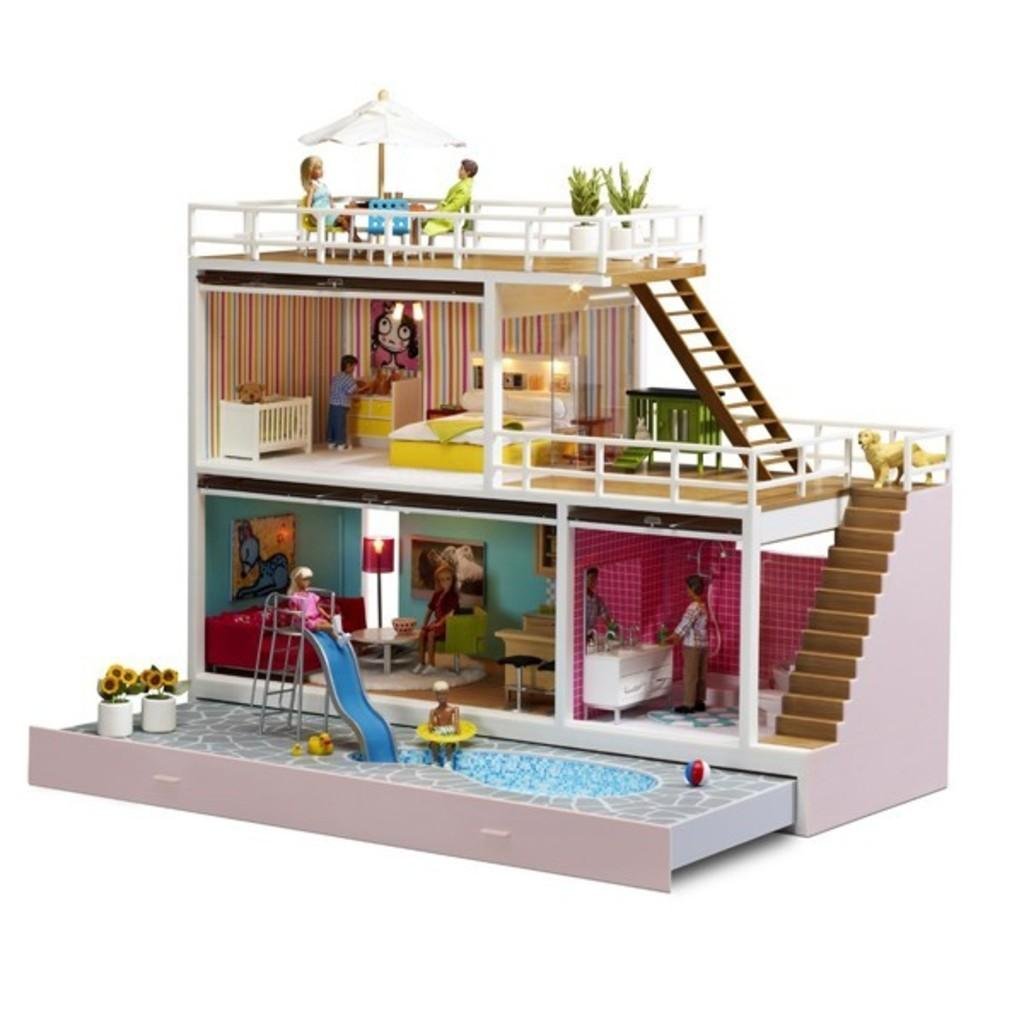What is the main structure in the image? There is a doll house in the image. What features does the doll house have? The doll house has a staircase and a ladder. What else can be found inside the doll house? There are plants and people inside the doll house. What is the name of the person who lives in the doll house? There is no specific person mentioned in the image, and therefore no name can be provided. 